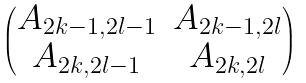Convert formula to latex. <formula><loc_0><loc_0><loc_500><loc_500>\begin{pmatrix} A _ { 2 k - 1 , 2 l - 1 } & A _ { 2 k - 1 , 2 l } \\ A _ { 2 k , 2 l - 1 } & A _ { 2 k , 2 l } \end{pmatrix}</formula> 